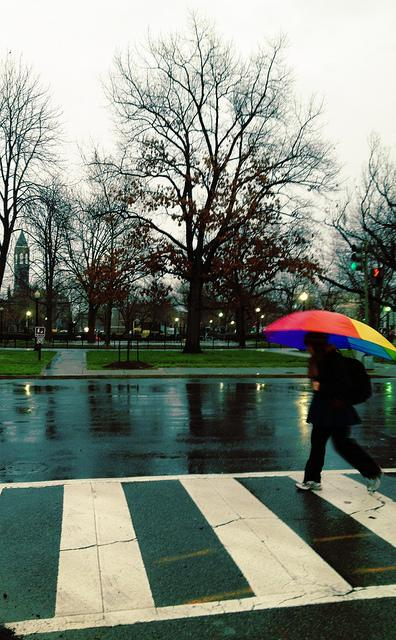What is the person with the umbrella walking on? Please explain your reasoning. zebra stripes. The are stripes. 